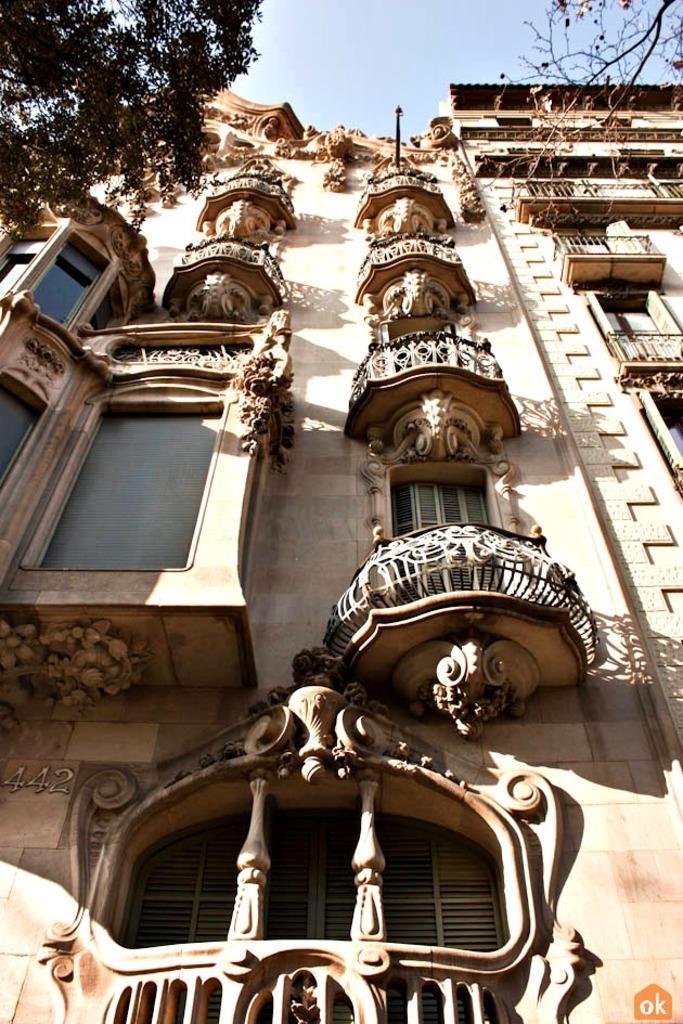Please provide a concise description of this image. In the given image i can see a heritage building included with windows,trees and in the background i can see the sky. 